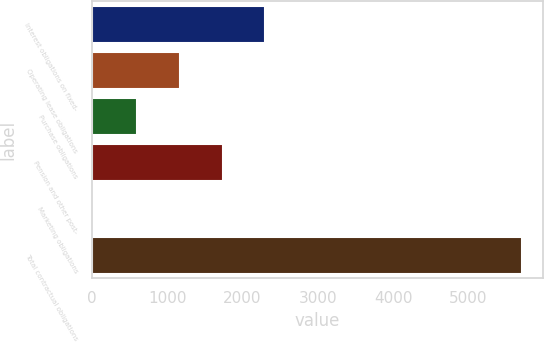<chart> <loc_0><loc_0><loc_500><loc_500><bar_chart><fcel>Interest obligations on fixed-<fcel>Operating lease obligations<fcel>Purchase obligations<fcel>Pension and other post-<fcel>Marketing obligations<fcel>Total contractual obligations<nl><fcel>2302.52<fcel>1167.06<fcel>599.33<fcel>1734.79<fcel>31.6<fcel>5708.9<nl></chart> 